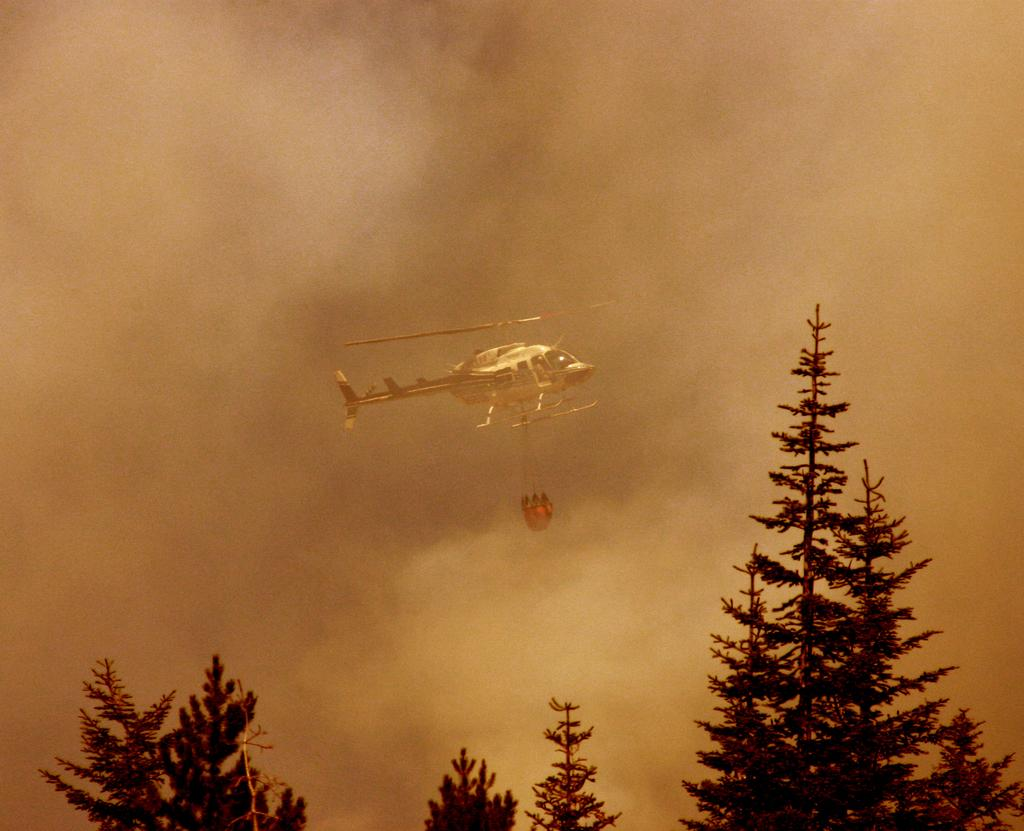What is located in the foreground of the image? There are trees in the foreground of the image. What is the main subject in the middle of the image? There is a helicopter in the middle of the image. What else can be seen in the middle of the image besides the helicopter? There is an object in the middle of the image. What is visible at the top of the image? The sky is visible at the top of the image. Can you see the sun shining in the image? The provided facts do not mention the sun, so we cannot determine if it is visible in the image. Is there a hand holding the helicopter in the image? There is no mention of a hand or anyone holding the helicopter in the image. 